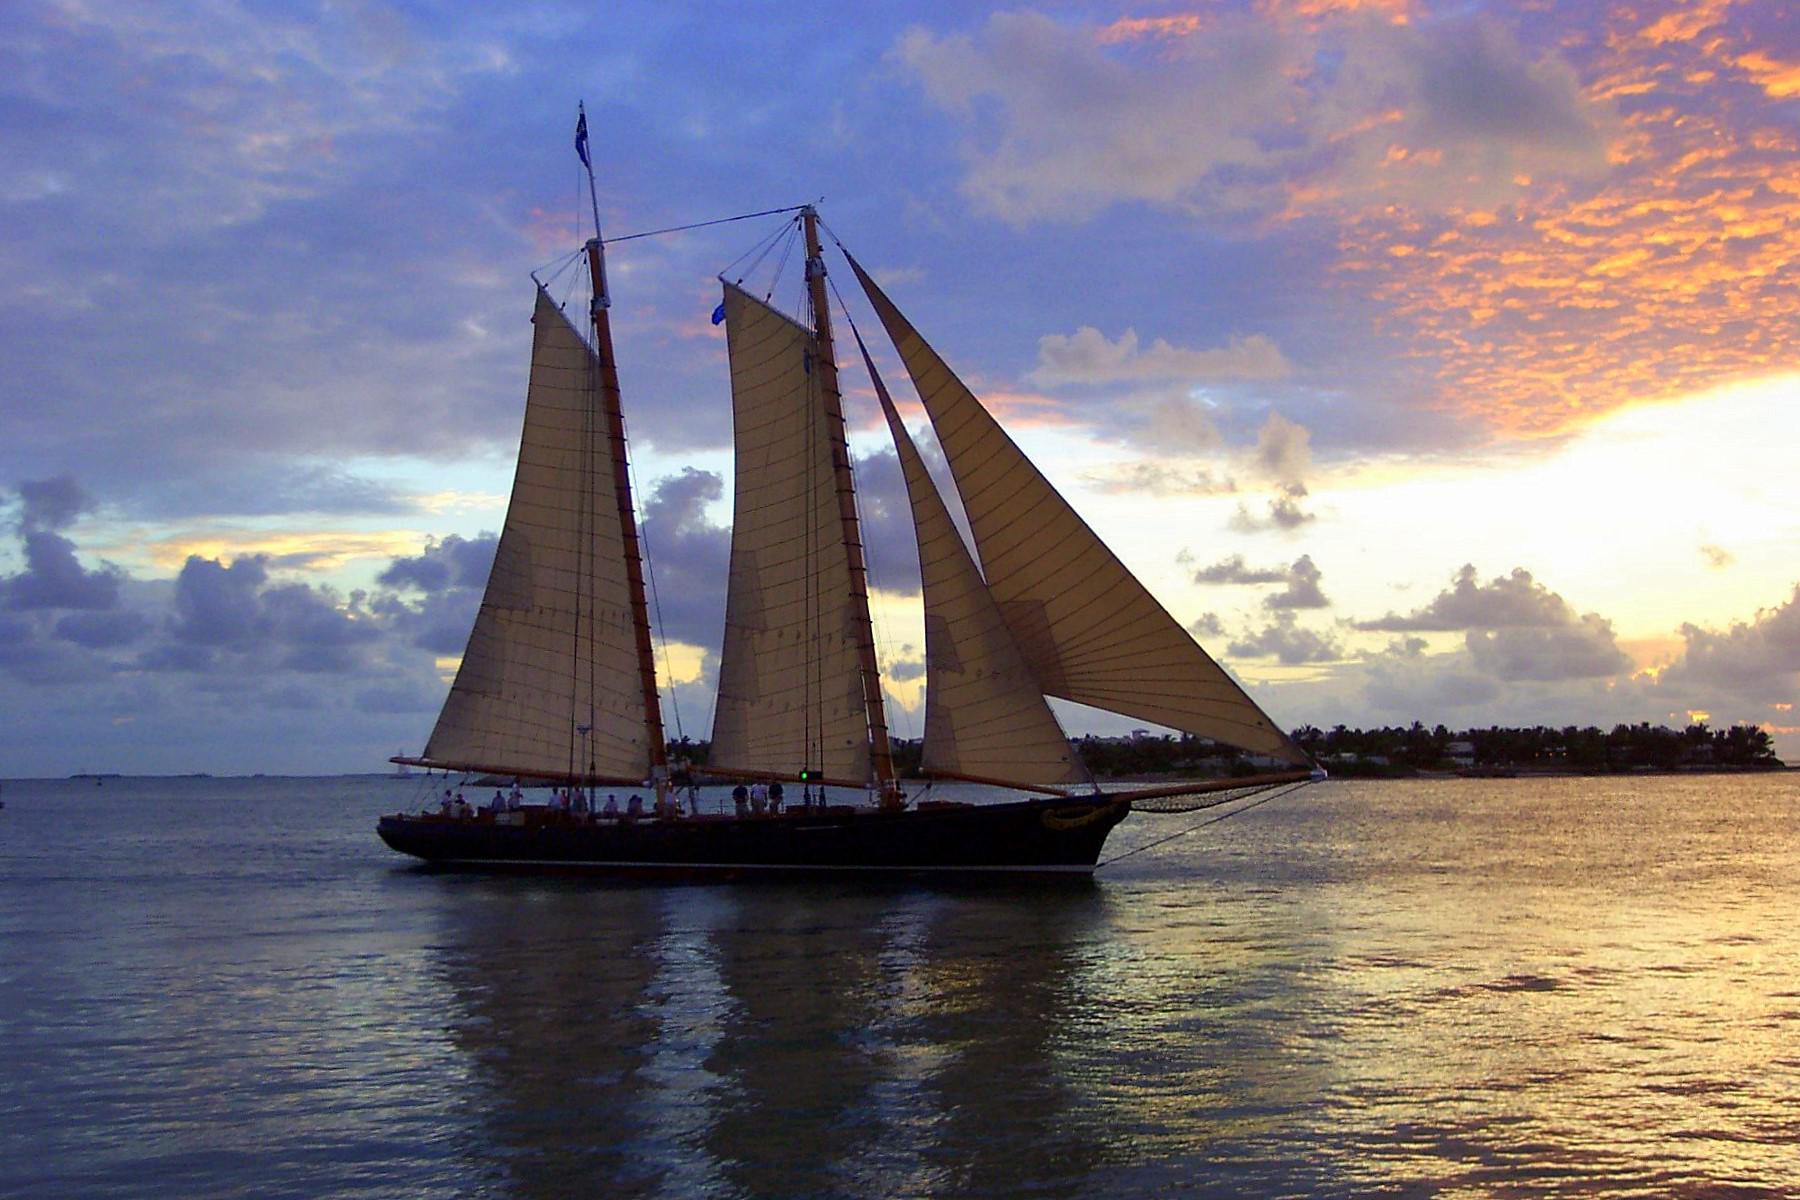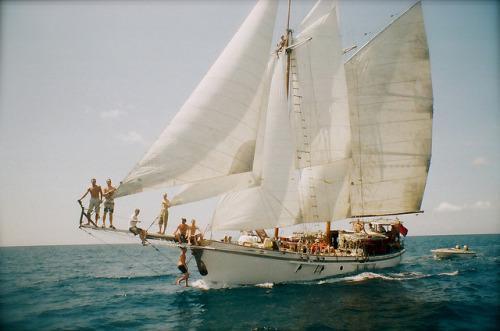The first image is the image on the left, the second image is the image on the right. For the images shown, is this caption "There are exactly two sailboats on the water." true? Answer yes or no. Yes. The first image is the image on the left, the second image is the image on the right. Considering the images on both sides, is "There are at least three sailboats on the water." valid? Answer yes or no. No. 